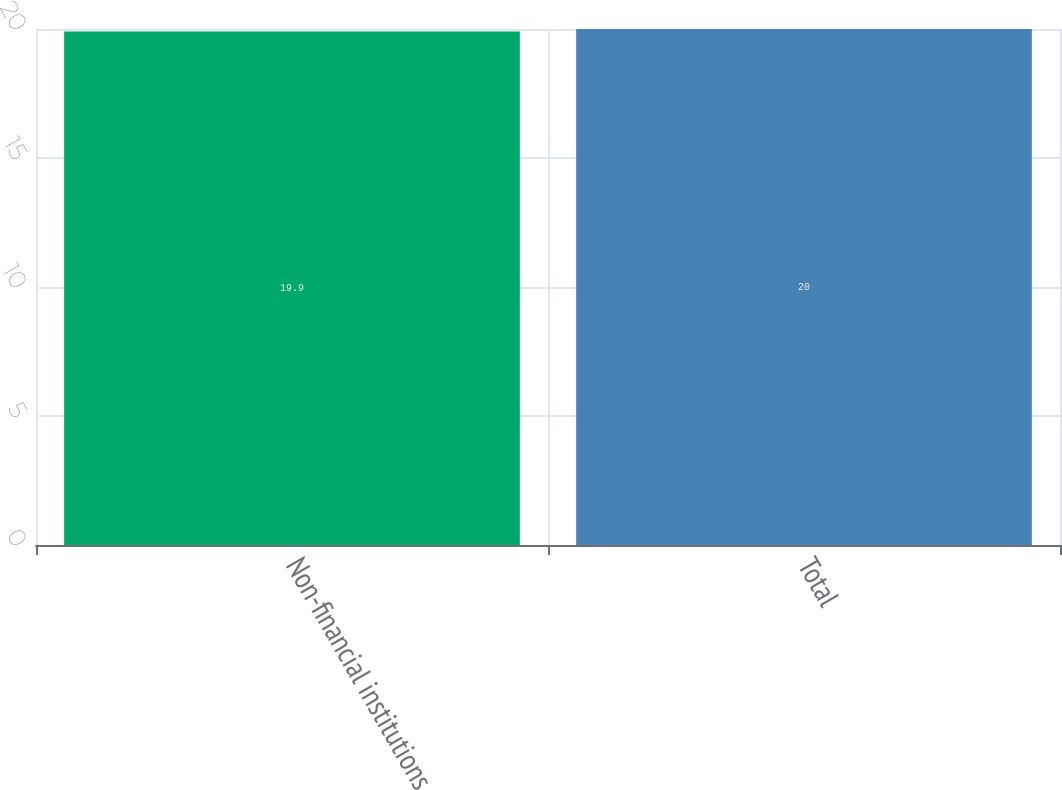Convert chart to OTSL. <chart><loc_0><loc_0><loc_500><loc_500><bar_chart><fcel>Non-financial institutions<fcel>Total<nl><fcel>19.9<fcel>20<nl></chart> 